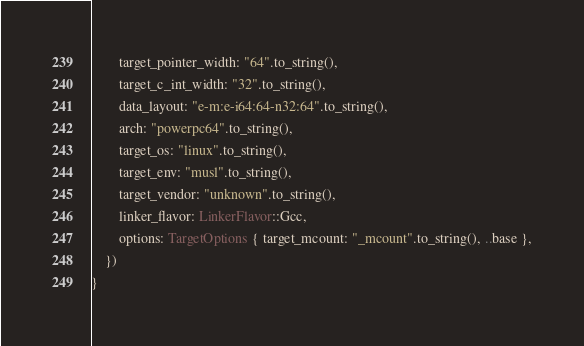<code> <loc_0><loc_0><loc_500><loc_500><_Rust_>        target_pointer_width: "64".to_string(),
        target_c_int_width: "32".to_string(),
        data_layout: "e-m:e-i64:64-n32:64".to_string(),
        arch: "powerpc64".to_string(),
        target_os: "linux".to_string(),
        target_env: "musl".to_string(),
        target_vendor: "unknown".to_string(),
        linker_flavor: LinkerFlavor::Gcc,
        options: TargetOptions { target_mcount: "_mcount".to_string(), ..base },
    })
}
</code> 